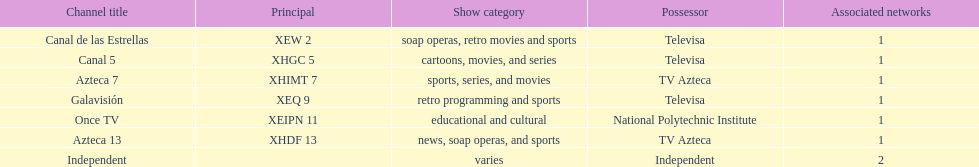How many affiliates does galavision have? 1. 